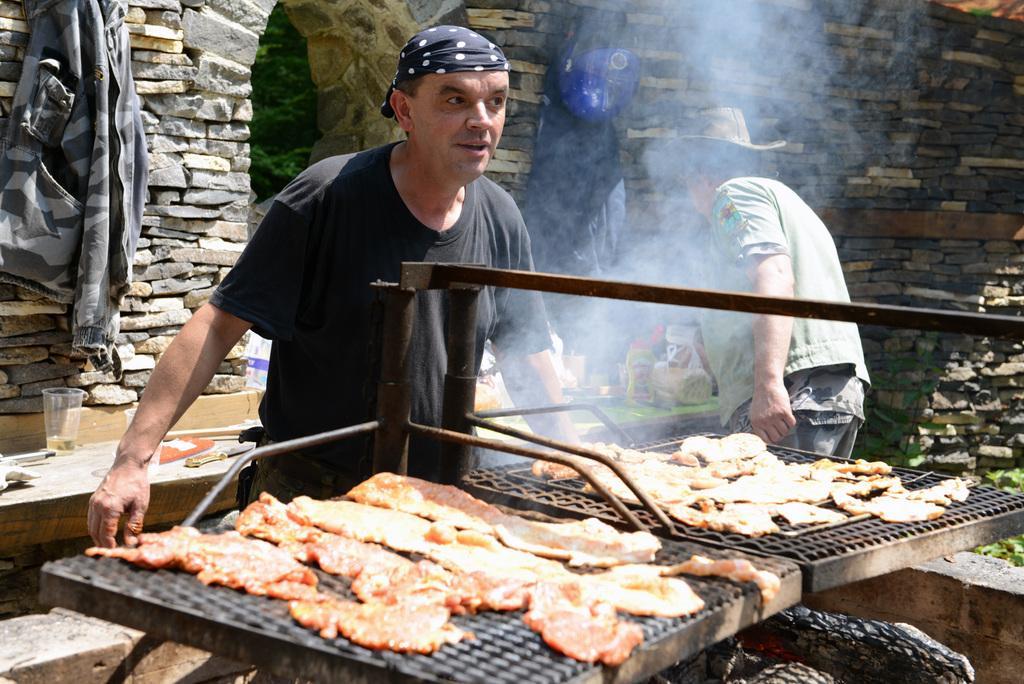Can you describe this image briefly? In this picture we can see some food items on the grills. There is smoke visible in the air. We can see two people standing. There is a cup, knife, bottle and other objects on a wooden table. We can see a jacket and a blue object on the stone walls. There are few rods. 